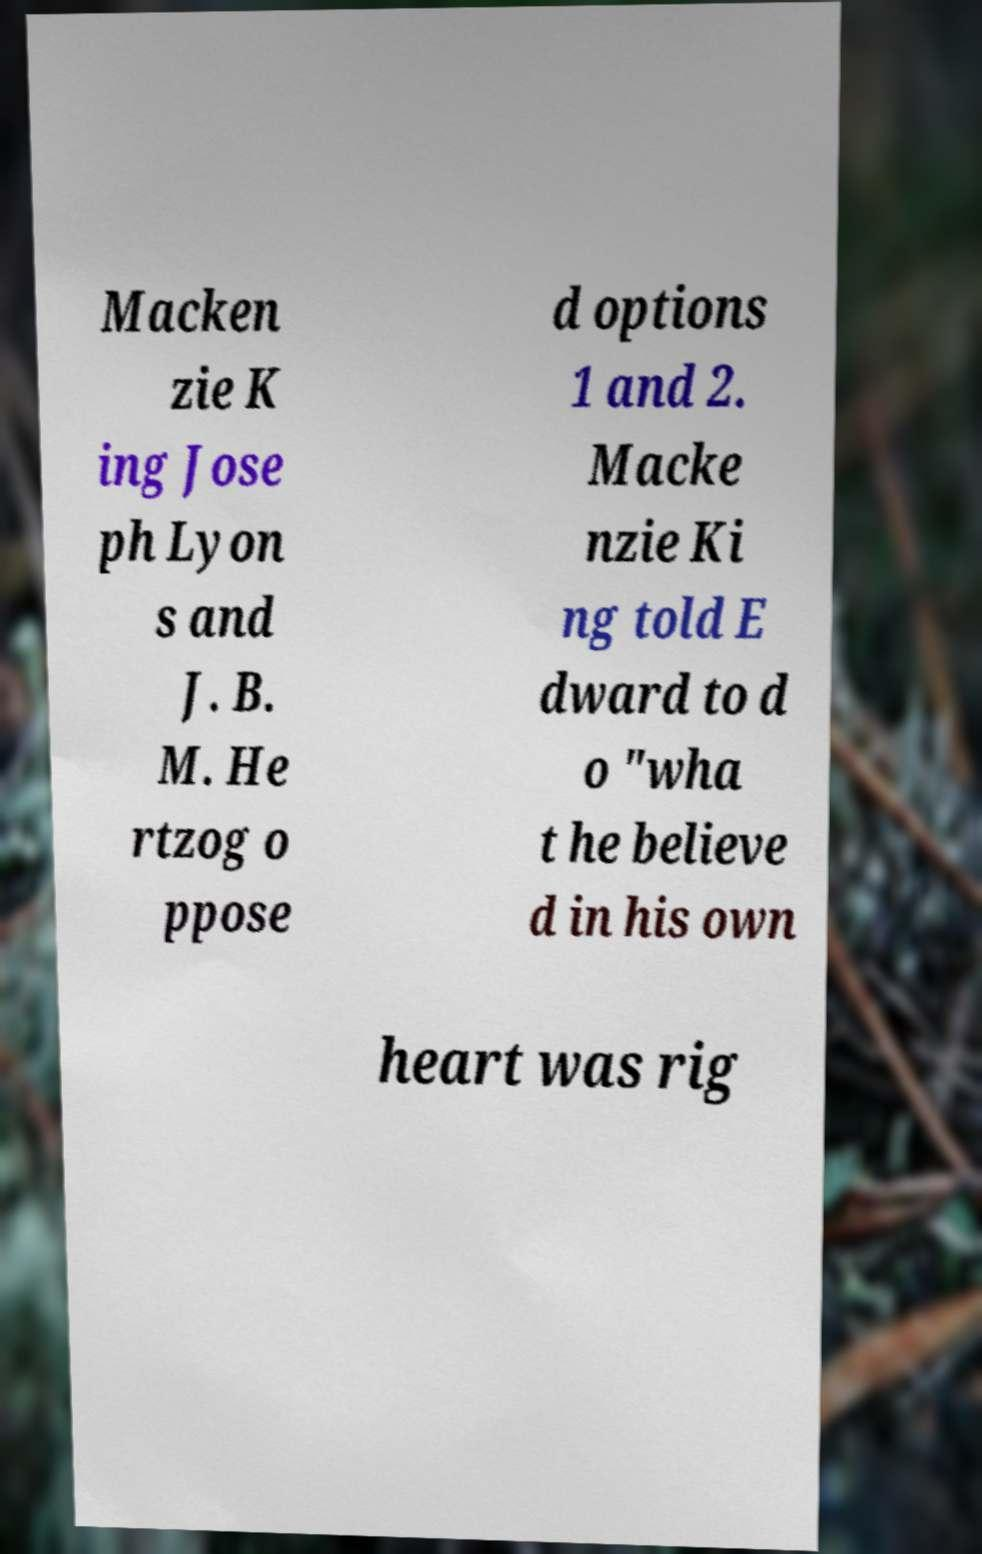Please read and relay the text visible in this image. What does it say? Macken zie K ing Jose ph Lyon s and J. B. M. He rtzog o ppose d options 1 and 2. Macke nzie Ki ng told E dward to d o "wha t he believe d in his own heart was rig 